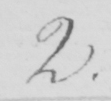What does this handwritten line say? 2 . 